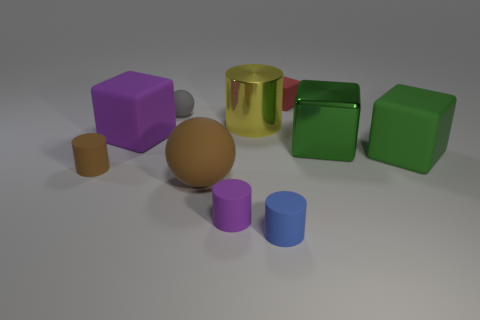What shape is the gray rubber object?
Your answer should be compact. Sphere. Is the big metallic cube the same color as the metal cylinder?
Give a very brief answer. No. How many objects are either objects behind the large cylinder or big gray cylinders?
Your response must be concise. 2. What is the size of the green cube that is made of the same material as the tiny red thing?
Keep it short and to the point. Large. Are there more large green metallic cubes that are to the left of the large green shiny object than tiny cubes?
Provide a short and direct response. No. There is a tiny red thing; is it the same shape as the big matte object that is behind the green rubber thing?
Keep it short and to the point. Yes. How many small objects are green matte spheres or green things?
Make the answer very short. 0. There is a cylinder that is the same color as the large rubber sphere; what size is it?
Your answer should be very brief. Small. There is a big metallic object in front of the large cube on the left side of the large yellow shiny cylinder; what is its color?
Provide a short and direct response. Green. Do the big yellow cylinder and the purple thing that is right of the big brown object have the same material?
Make the answer very short. No. 